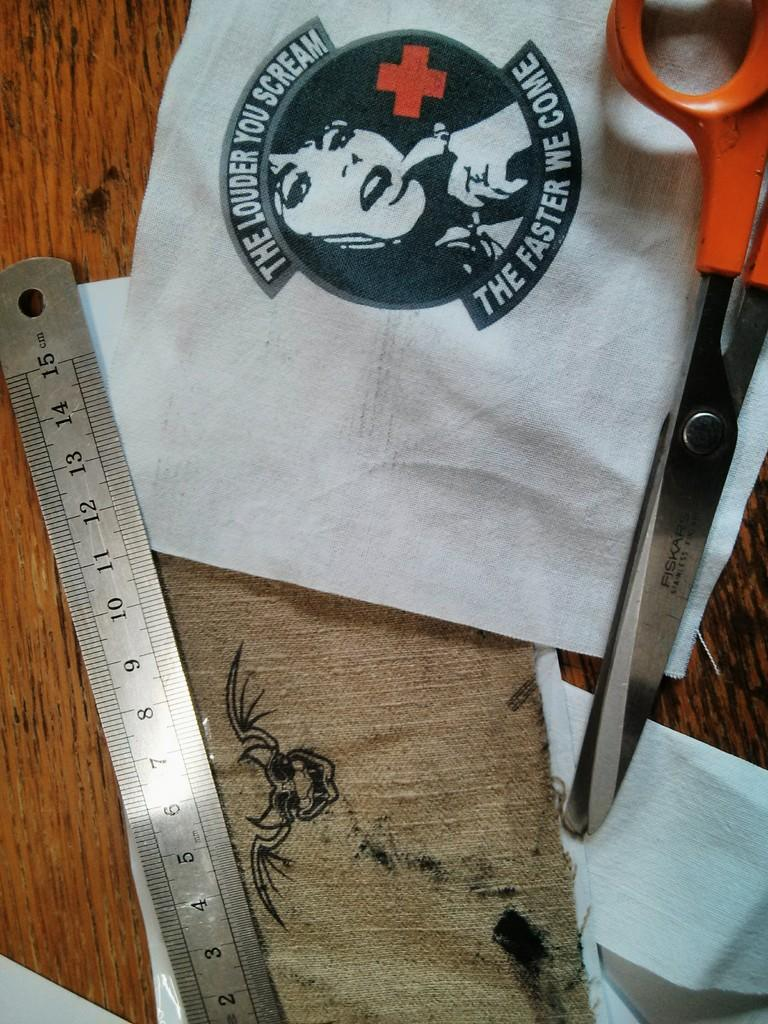<image>
Render a clear and concise summary of the photo. an image on a fabric that says The Faster We Come on it 